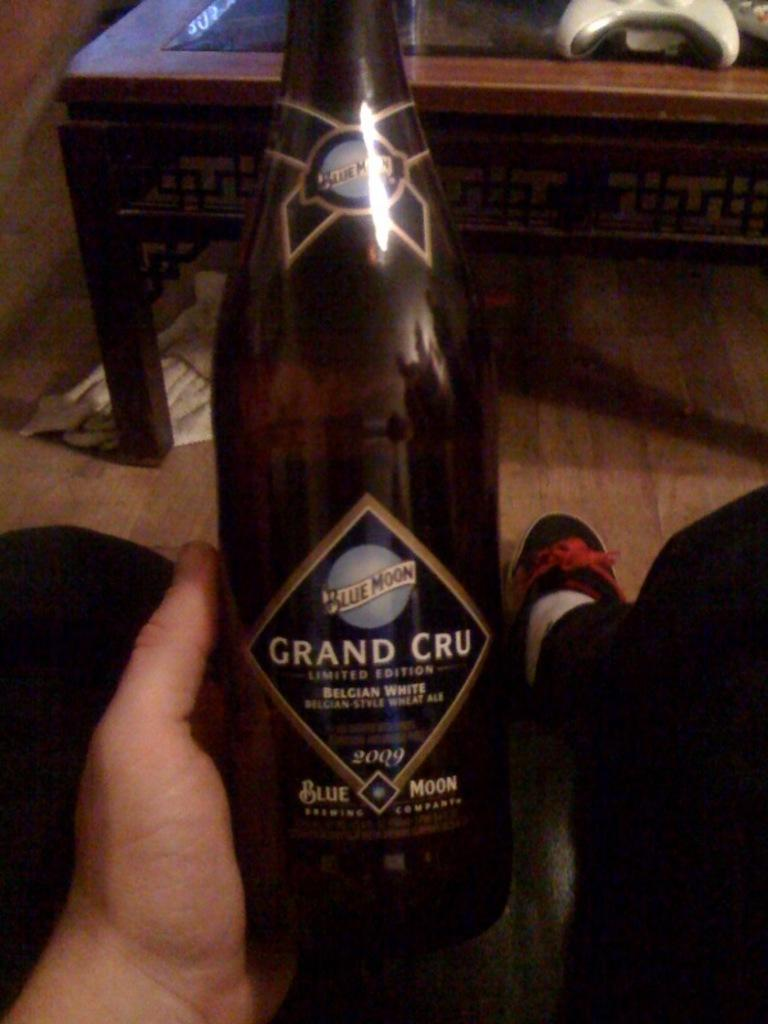<image>
Summarize the visual content of the image. A large bottle of beer named Grand Cru distributed by Blue Moon. 